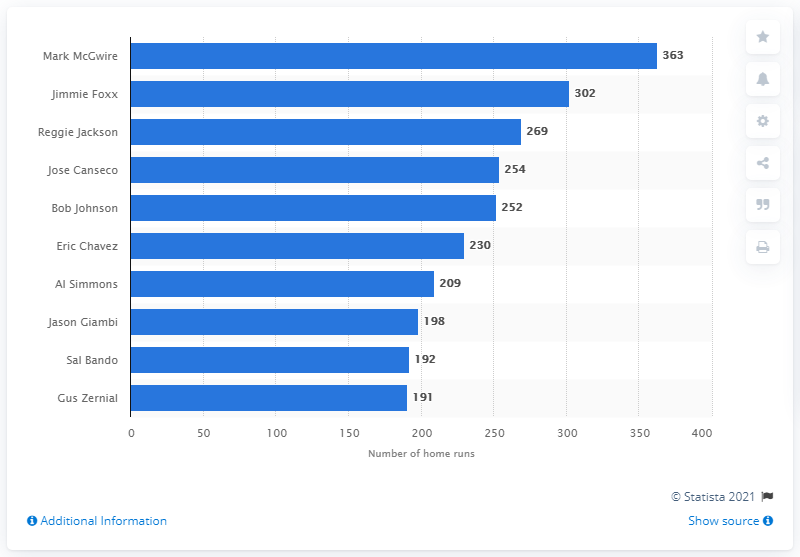Highlight a few significant elements in this photo. Mark McGwire has hit a total of 363 home runs in his career. Mark McGwire is the player who has hit the most home runs in the history of the Oakland Athletics franchise. 